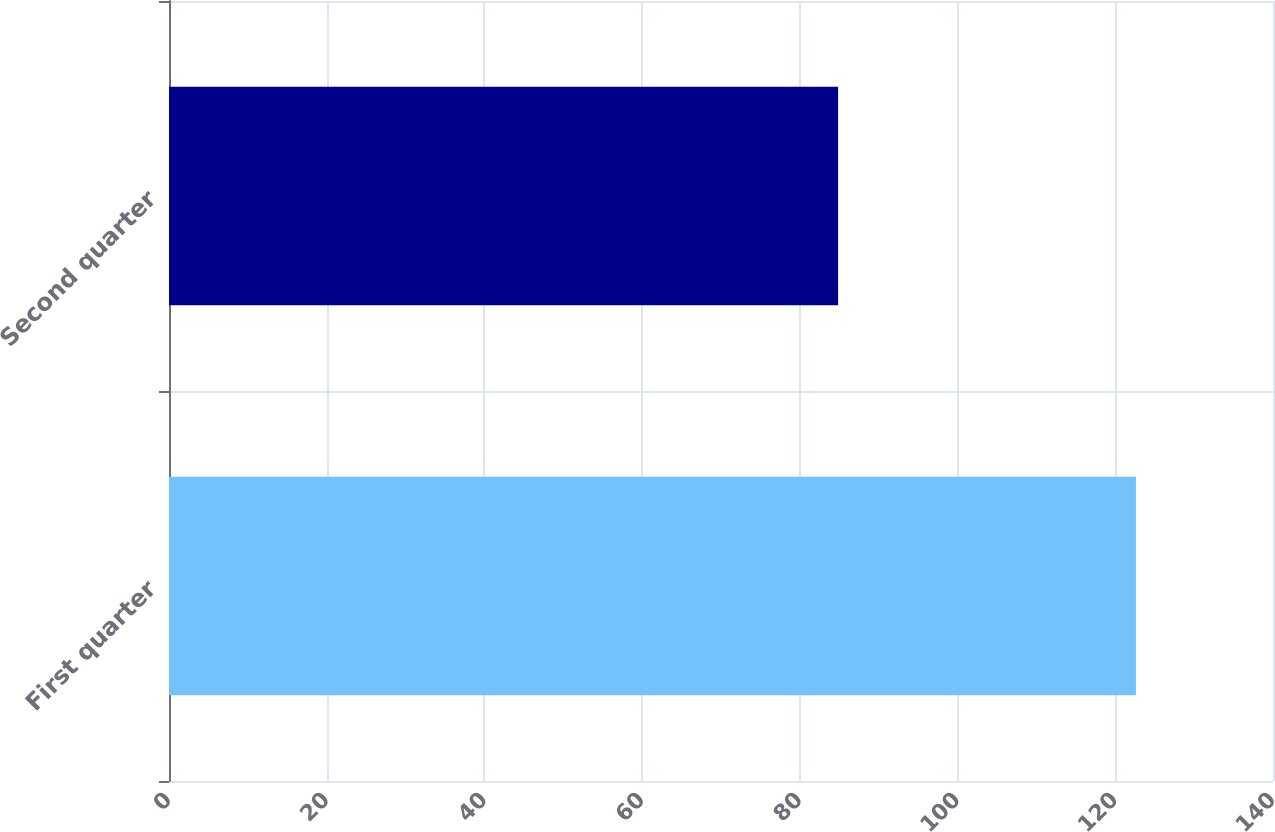<chart> <loc_0><loc_0><loc_500><loc_500><bar_chart><fcel>First quarter<fcel>Second quarter<nl><fcel>122.62<fcel>84.85<nl></chart> 